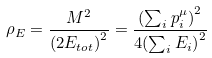<formula> <loc_0><loc_0><loc_500><loc_500>\rho _ { E } = \frac { M ^ { 2 } } { { ( 2 E _ { t o t } ) } ^ { 2 } } = \frac { { ( \sum _ { i } p ^ { \mu } _ { i } ) } ^ { 2 } } { 4 { ( \sum _ { i } E _ { i } ) } ^ { 2 } }</formula> 